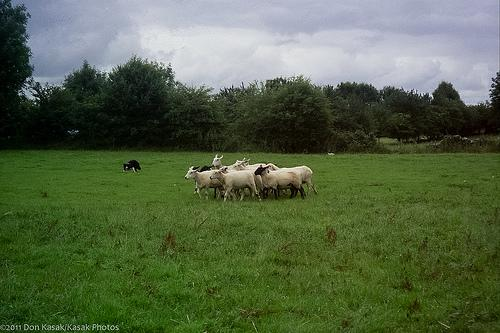Question: where is this scene?
Choices:
A. At the dentist.
B. In California.
C. Canada.
D. In a field.
Answer with the letter. Answer: D Question: when is this?
Choices:
A. Nighttime.
B. Just after sunset.
C. Just before sunrise.
D. Daytime.
Answer with the letter. Answer: D Question: what animals are these?
Choices:
A. Goats.
B. Wolves.
C. Sheep.
D. Pigs.
Answer with the letter. Answer: C Question: what else is in the photo?
Choices:
A. Trees.
B. Rocks.
C. A hidden sniper.
D. Beach equipment.
Answer with the letter. Answer: A 